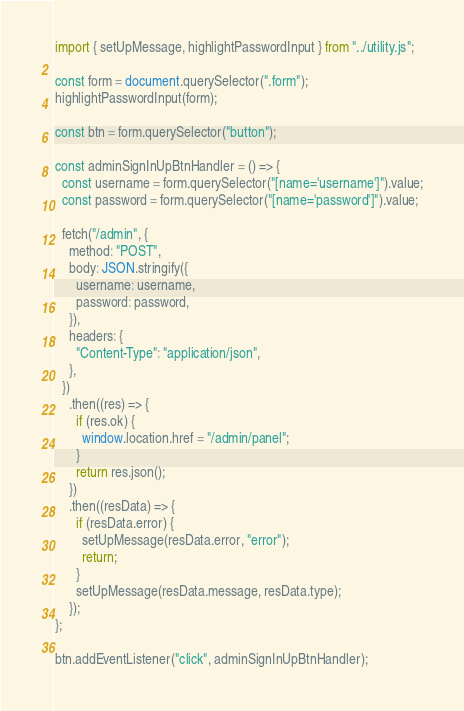<code> <loc_0><loc_0><loc_500><loc_500><_JavaScript_>import { setUpMessage, highlightPasswordInput } from "../utility.js";

const form = document.querySelector(".form");
highlightPasswordInput(form);

const btn = form.querySelector("button");

const adminSignInUpBtnHandler = () => {
  const username = form.querySelector("[name='username']").value;
  const password = form.querySelector("[name='password']").value;

  fetch("/admin", {
    method: "POST",
    body: JSON.stringify({
      username: username,
      password: password,
    }),
    headers: {
      "Content-Type": "application/json",
    },
  })
    .then((res) => {
      if (res.ok) {
        window.location.href = "/admin/panel";
      }
      return res.json();
    })
    .then((resData) => {
      if (resData.error) {
        setUpMessage(resData.error, "error");
        return;
      }
      setUpMessage(resData.message, resData.type);
    });
};

btn.addEventListener("click", adminSignInUpBtnHandler);
</code> 